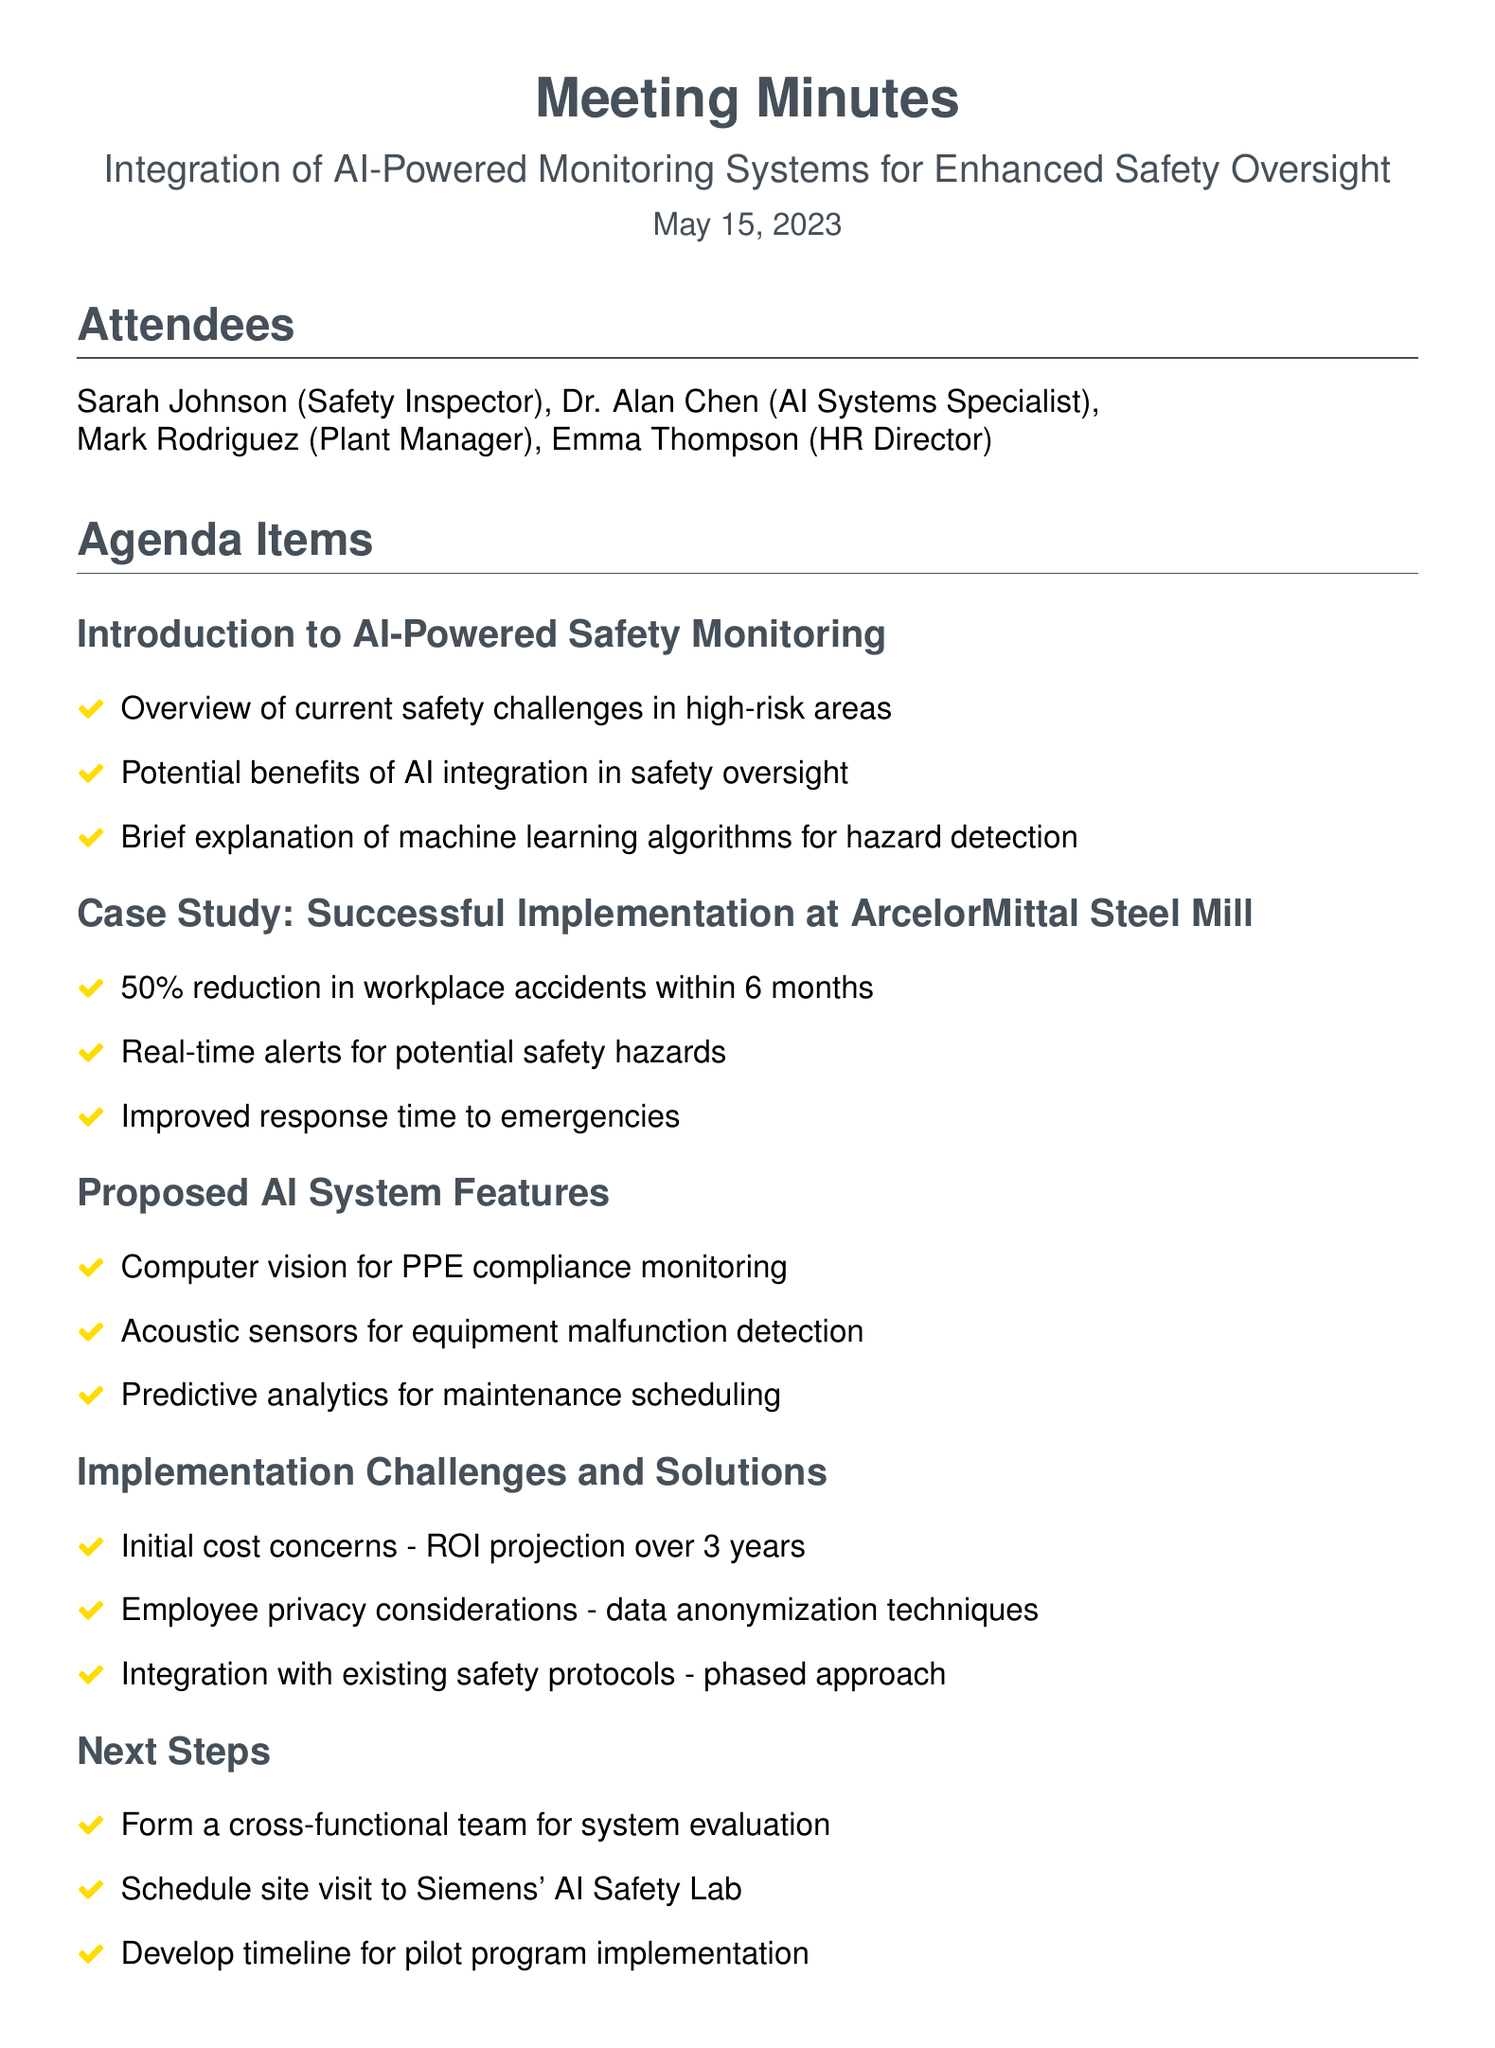What is the date of the meeting? The date of the meeting is stated at the beginning of the document.
Answer: May 15, 2023 Who is the HR Director attending the meeting? The attendees section lists the names and roles of the people present in the meeting.
Answer: Emma Thompson What system feature is related to monitoring PPE compliance? The proposed system features are listed under their respective agenda item in the document.
Answer: Computer vision What was the result of the case study at ArcelorMittal Steel Mill? The case study section summarizes the outcomes regarding workplace accidents presented in the document.
Answer: 50% reduction in workplace accidents within 6 months What is the due date for the detailed cost-benefit analysis? The action items section specifies tasks, assignees, and their respective due dates.
Answer: June 1, 2023 What are the employee privacy considerations mentioned? The implementation challenges section addresses specific issues related to privacy in the document.
Answer: Data anonymization techniques What is the first step listed under the next steps? The next steps section outlines actions to be taken after the discussion, specifically under this agenda item.
Answer: Form a cross-functional team for system evaluation What is the focus of the meeting? The title of the meeting provides information about the main theme discussed throughout the document.
Answer: Integration of AI-Powered Monitoring Systems for Enhanced Safety Oversight 